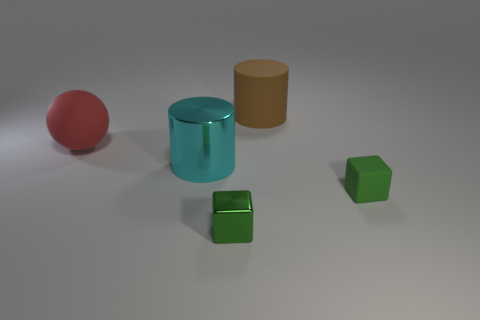There is another thing that is the same shape as the small rubber object; what is its material?
Offer a terse response. Metal. Is the size of the green thing in front of the green rubber thing the same as the cyan shiny object?
Offer a terse response. No. There is a matte sphere; what number of big cylinders are in front of it?
Your answer should be compact. 1. Are there fewer matte objects behind the large red sphere than cyan cylinders behind the cyan cylinder?
Provide a succinct answer. No. How many cylinders are there?
Ensure brevity in your answer.  2. The big matte thing on the right side of the shiny block is what color?
Ensure brevity in your answer.  Brown. How big is the green matte object?
Your response must be concise. Small. There is a rubber cylinder; is it the same color as the big cylinder on the left side of the brown matte thing?
Your response must be concise. No. What is the color of the shiny thing that is in front of the matte cube in front of the big ball?
Offer a very short reply. Green. There is a big object right of the green shiny block; does it have the same shape as the big red object?
Your response must be concise. No. 